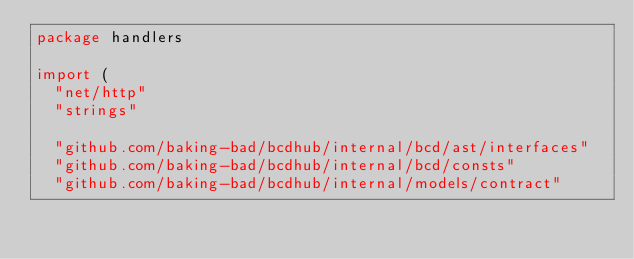<code> <loc_0><loc_0><loc_500><loc_500><_Go_>package handlers

import (
	"net/http"
	"strings"

	"github.com/baking-bad/bcdhub/internal/bcd/ast/interfaces"
	"github.com/baking-bad/bcdhub/internal/bcd/consts"
	"github.com/baking-bad/bcdhub/internal/models/contract"</code> 